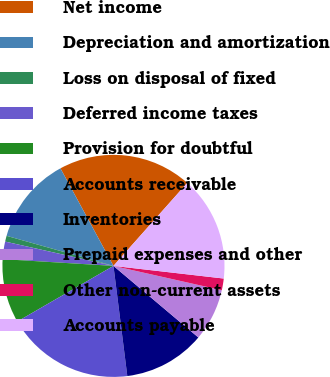Convert chart. <chart><loc_0><loc_0><loc_500><loc_500><pie_chart><fcel>Net income<fcel>Depreciation and amortization<fcel>Loss on disposal of fixed<fcel>Deferred income taxes<fcel>Provision for doubtful<fcel>Accounts receivable<fcel>Inventories<fcel>Prepaid expenses and other<fcel>Other non-current assets<fcel>Accounts payable<nl><fcel>19.49%<fcel>12.71%<fcel>0.85%<fcel>2.54%<fcel>9.32%<fcel>18.64%<fcel>11.86%<fcel>7.63%<fcel>1.7%<fcel>15.25%<nl></chart> 